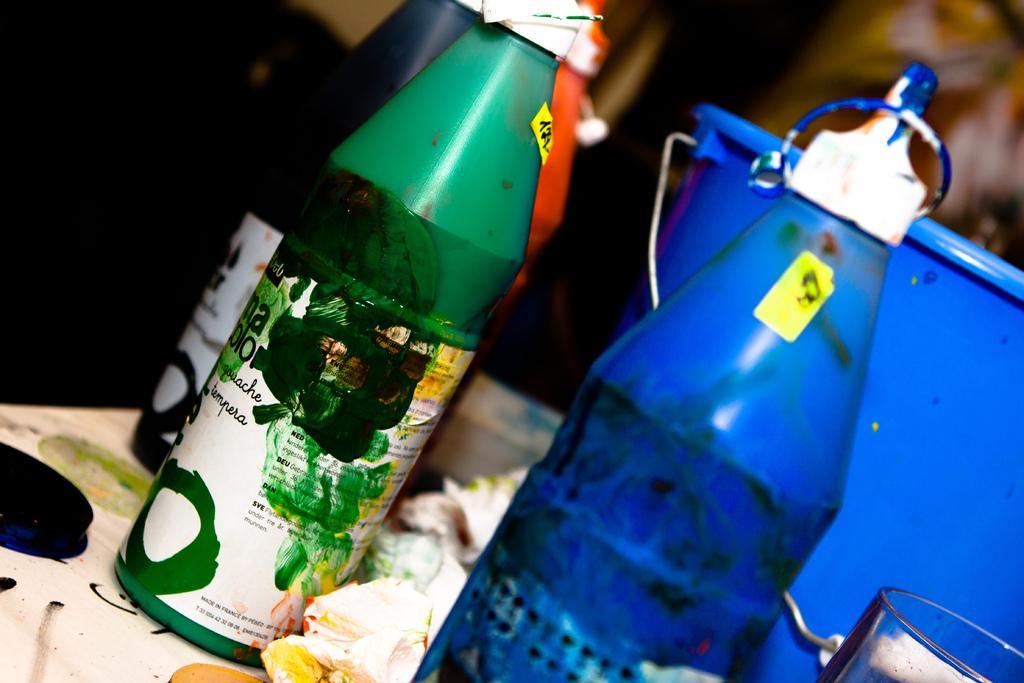Could you give a brief overview of what you see in this image? This picture shows few color bottles and a bucket on the table 